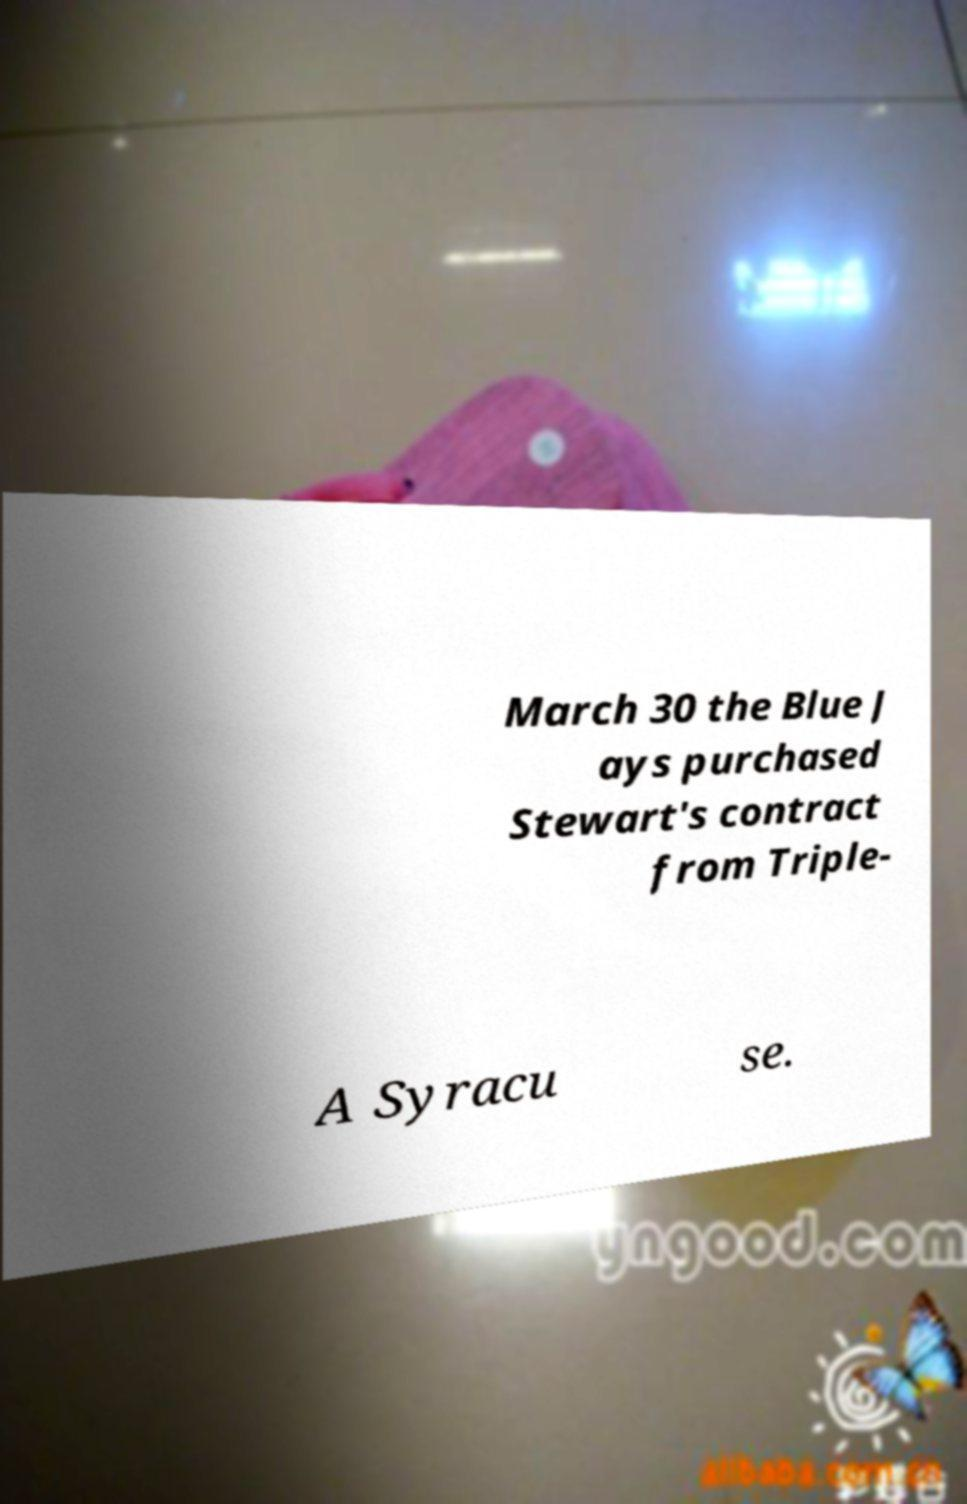Can you accurately transcribe the text from the provided image for me? March 30 the Blue J ays purchased Stewart's contract from Triple- A Syracu se. 